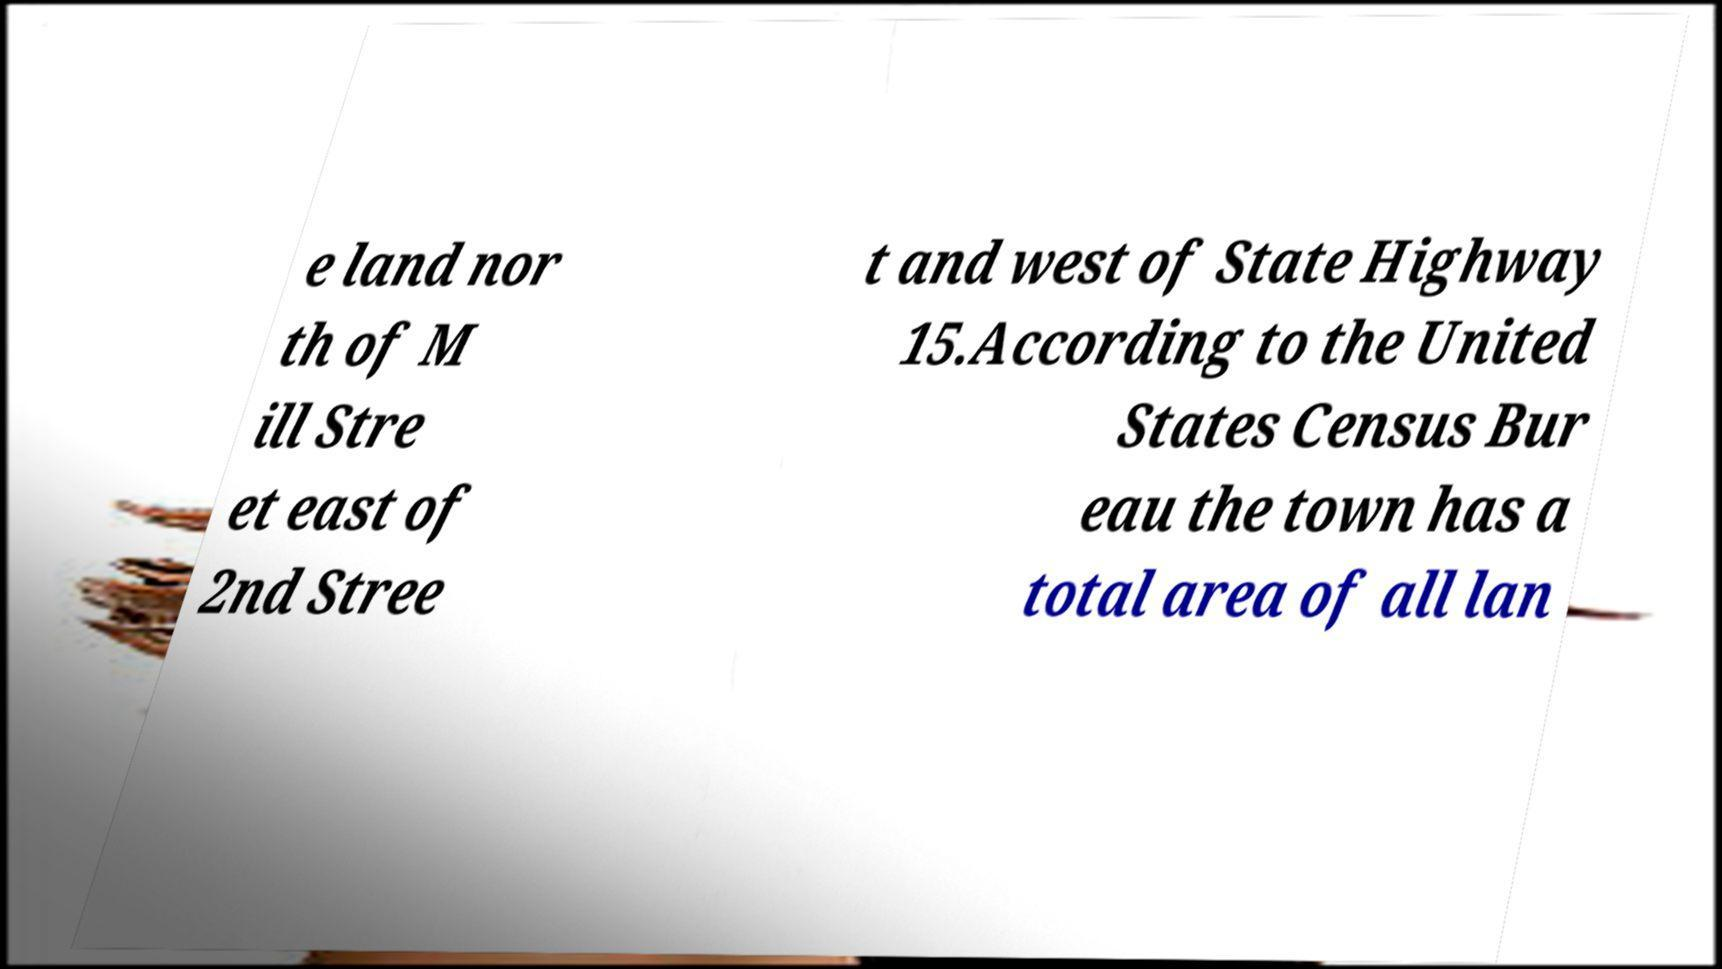What messages or text are displayed in this image? I need them in a readable, typed format. e land nor th of M ill Stre et east of 2nd Stree t and west of State Highway 15.According to the United States Census Bur eau the town has a total area of all lan 